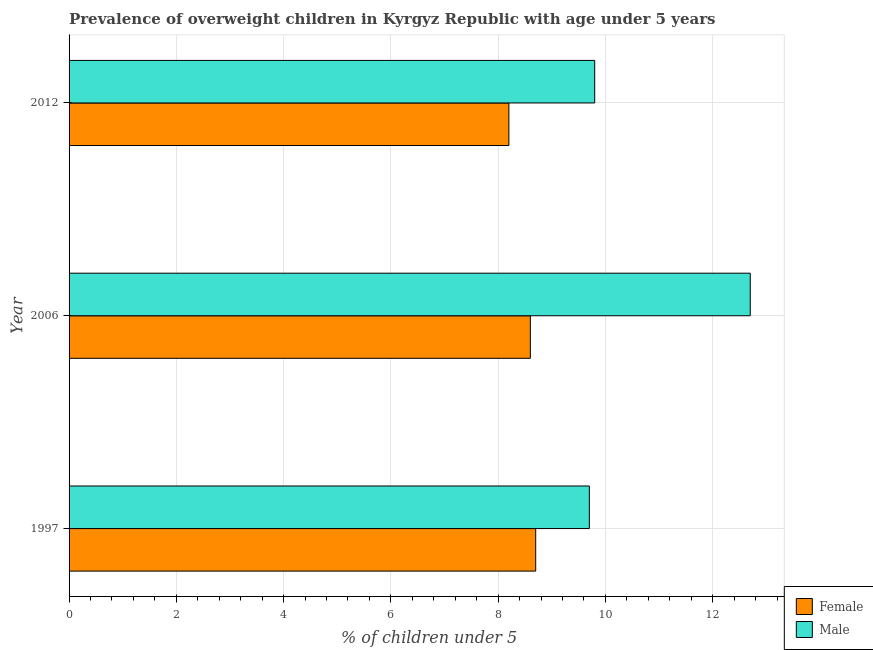How many groups of bars are there?
Your answer should be very brief. 3. Are the number of bars on each tick of the Y-axis equal?
Keep it short and to the point. Yes. How many bars are there on the 2nd tick from the bottom?
Your answer should be very brief. 2. In how many cases, is the number of bars for a given year not equal to the number of legend labels?
Provide a short and direct response. 0. What is the percentage of obese female children in 2006?
Make the answer very short. 8.6. Across all years, what is the maximum percentage of obese male children?
Offer a terse response. 12.7. Across all years, what is the minimum percentage of obese female children?
Provide a short and direct response. 8.2. In which year was the percentage of obese male children minimum?
Your answer should be compact. 1997. What is the total percentage of obese female children in the graph?
Your answer should be compact. 25.5. What is the difference between the percentage of obese female children in 2006 and the percentage of obese male children in 2012?
Provide a succinct answer. -1.2. What is the average percentage of obese male children per year?
Give a very brief answer. 10.73. What is the ratio of the percentage of obese male children in 2006 to that in 2012?
Offer a very short reply. 1.3. Is the percentage of obese male children in 1997 less than that in 2012?
Provide a short and direct response. Yes. Is the difference between the percentage of obese female children in 1997 and 2006 greater than the difference between the percentage of obese male children in 1997 and 2006?
Keep it short and to the point. Yes. What is the difference between the highest and the second highest percentage of obese female children?
Offer a terse response. 0.1. In how many years, is the percentage of obese male children greater than the average percentage of obese male children taken over all years?
Keep it short and to the point. 1. What does the 2nd bar from the bottom in 2012 represents?
Your answer should be very brief. Male. How many bars are there?
Provide a short and direct response. 6. Are all the bars in the graph horizontal?
Provide a short and direct response. Yes. What is the difference between two consecutive major ticks on the X-axis?
Your answer should be very brief. 2. Are the values on the major ticks of X-axis written in scientific E-notation?
Provide a succinct answer. No. Does the graph contain grids?
Give a very brief answer. Yes. How many legend labels are there?
Provide a short and direct response. 2. How are the legend labels stacked?
Provide a succinct answer. Vertical. What is the title of the graph?
Your answer should be compact. Prevalence of overweight children in Kyrgyz Republic with age under 5 years. What is the label or title of the X-axis?
Make the answer very short.  % of children under 5. What is the  % of children under 5 in Female in 1997?
Ensure brevity in your answer.  8.7. What is the  % of children under 5 in Male in 1997?
Give a very brief answer. 9.7. What is the  % of children under 5 of Female in 2006?
Offer a terse response. 8.6. What is the  % of children under 5 in Male in 2006?
Your answer should be very brief. 12.7. What is the  % of children under 5 in Female in 2012?
Provide a succinct answer. 8.2. What is the  % of children under 5 of Male in 2012?
Offer a terse response. 9.8. Across all years, what is the maximum  % of children under 5 in Female?
Your response must be concise. 8.7. Across all years, what is the maximum  % of children under 5 of Male?
Keep it short and to the point. 12.7. Across all years, what is the minimum  % of children under 5 of Female?
Your answer should be compact. 8.2. Across all years, what is the minimum  % of children under 5 of Male?
Your answer should be very brief. 9.7. What is the total  % of children under 5 of Male in the graph?
Provide a short and direct response. 32.2. What is the difference between the  % of children under 5 of Female in 1997 and that in 2006?
Provide a succinct answer. 0.1. What is the difference between the  % of children under 5 of Male in 1997 and that in 2006?
Offer a terse response. -3. What is the difference between the  % of children under 5 in Female in 1997 and that in 2012?
Provide a short and direct response. 0.5. What is the difference between the  % of children under 5 of Male in 2006 and that in 2012?
Your answer should be very brief. 2.9. What is the average  % of children under 5 in Male per year?
Offer a very short reply. 10.73. In the year 2006, what is the difference between the  % of children under 5 in Female and  % of children under 5 in Male?
Your answer should be compact. -4.1. In the year 2012, what is the difference between the  % of children under 5 of Female and  % of children under 5 of Male?
Your answer should be very brief. -1.6. What is the ratio of the  % of children under 5 in Female in 1997 to that in 2006?
Provide a succinct answer. 1.01. What is the ratio of the  % of children under 5 in Male in 1997 to that in 2006?
Your answer should be compact. 0.76. What is the ratio of the  % of children under 5 of Female in 1997 to that in 2012?
Provide a short and direct response. 1.06. What is the ratio of the  % of children under 5 of Male in 1997 to that in 2012?
Your answer should be very brief. 0.99. What is the ratio of the  % of children under 5 of Female in 2006 to that in 2012?
Offer a terse response. 1.05. What is the ratio of the  % of children under 5 in Male in 2006 to that in 2012?
Provide a short and direct response. 1.3. What is the difference between the highest and the second highest  % of children under 5 of Male?
Keep it short and to the point. 2.9. What is the difference between the highest and the lowest  % of children under 5 in Female?
Make the answer very short. 0.5. What is the difference between the highest and the lowest  % of children under 5 in Male?
Give a very brief answer. 3. 